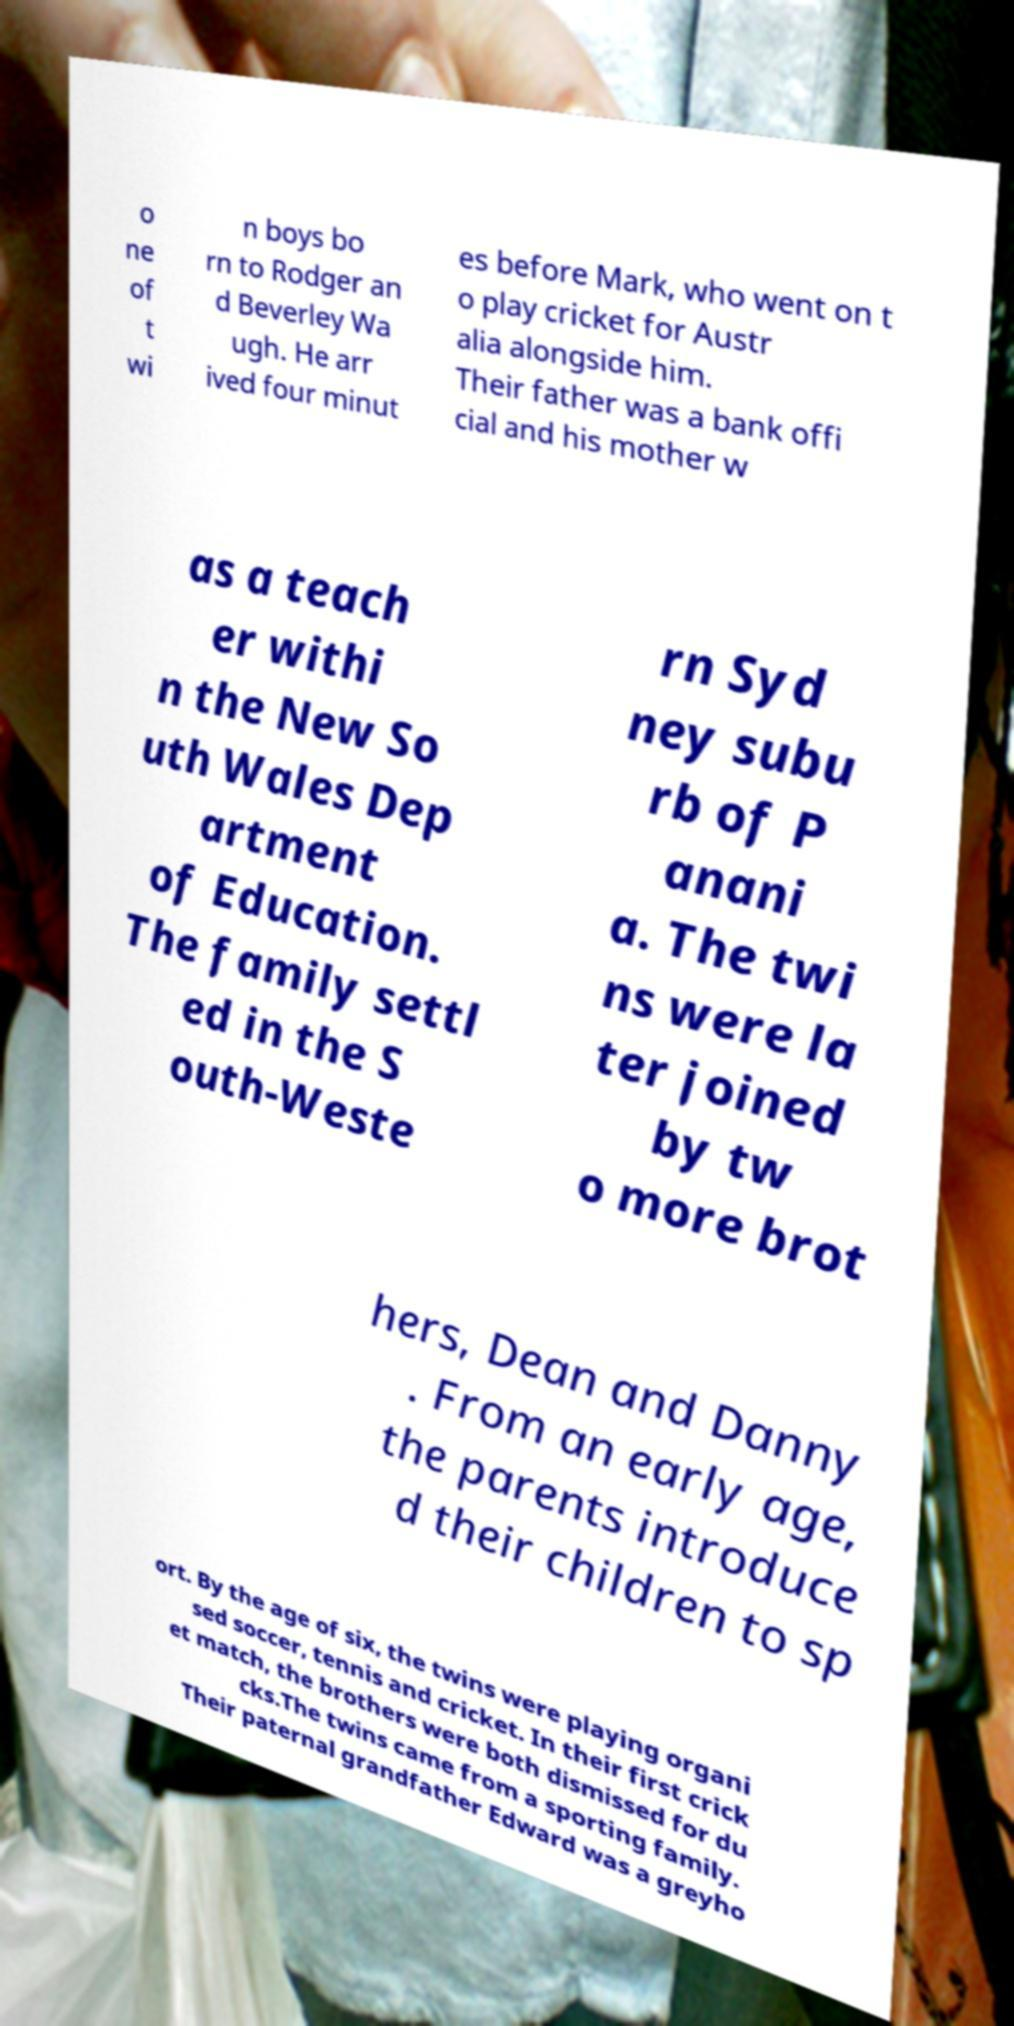For documentation purposes, I need the text within this image transcribed. Could you provide that? o ne of t wi n boys bo rn to Rodger an d Beverley Wa ugh. He arr ived four minut es before Mark, who went on t o play cricket for Austr alia alongside him. Their father was a bank offi cial and his mother w as a teach er withi n the New So uth Wales Dep artment of Education. The family settl ed in the S outh-Weste rn Syd ney subu rb of P anani a. The twi ns were la ter joined by tw o more brot hers, Dean and Danny . From an early age, the parents introduce d their children to sp ort. By the age of six, the twins were playing organi sed soccer, tennis and cricket. In their first crick et match, the brothers were both dismissed for du cks.The twins came from a sporting family. Their paternal grandfather Edward was a greyho 